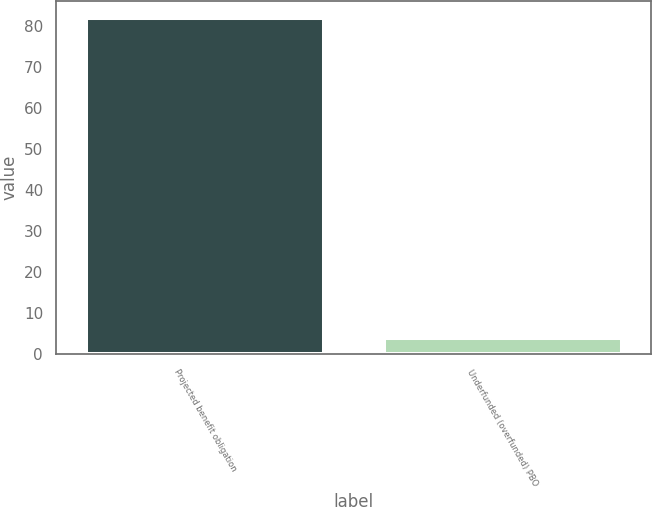Convert chart. <chart><loc_0><loc_0><loc_500><loc_500><bar_chart><fcel>Projected benefit obligation<fcel>Underfunded (overfunded) PBO<nl><fcel>82<fcel>4<nl></chart> 